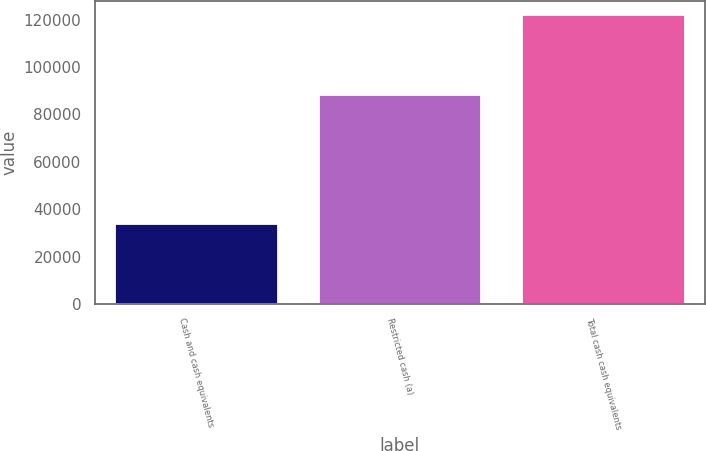<chart> <loc_0><loc_0><loc_500><loc_500><bar_chart><fcel>Cash and cash equivalents<fcel>Restricted cash (a)<fcel>Total cash cash equivalents<nl><fcel>33747<fcel>88203<fcel>121950<nl></chart> 